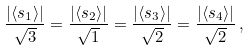<formula> <loc_0><loc_0><loc_500><loc_500>\frac { | \langle s _ { 1 } \rangle | } { \sqrt { 3 } } = \frac { | \langle s _ { 2 } \rangle | } { \sqrt { 1 } } = \frac { | \langle s _ { 3 } \rangle | } { \sqrt { 2 } } = \frac { | \langle s _ { 4 } \rangle | } { \sqrt { 2 } } \, ,</formula> 